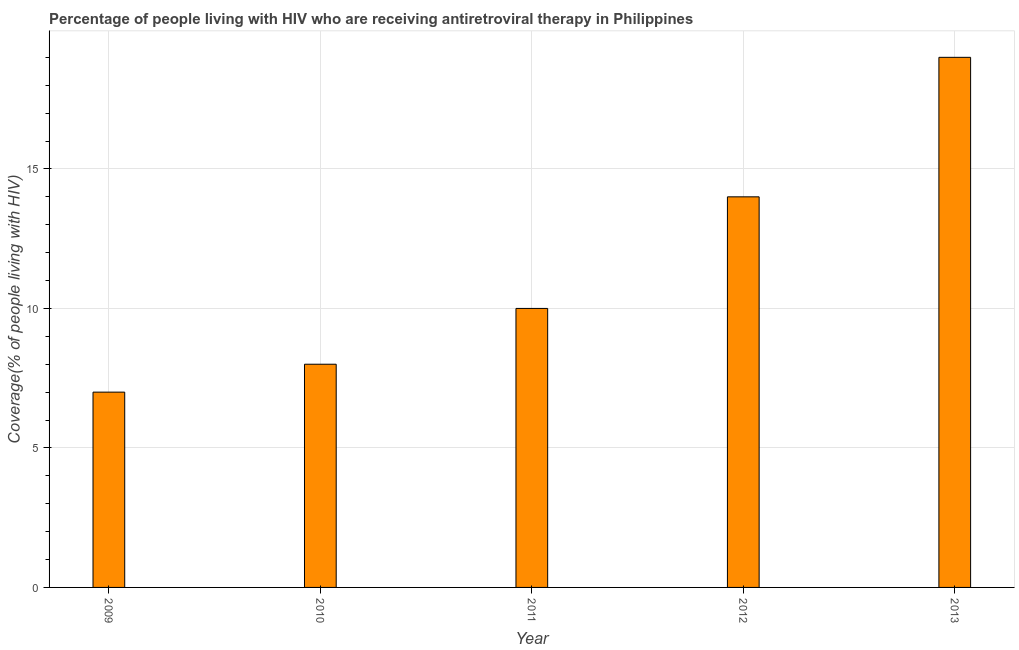What is the title of the graph?
Offer a very short reply. Percentage of people living with HIV who are receiving antiretroviral therapy in Philippines. What is the label or title of the Y-axis?
Give a very brief answer. Coverage(% of people living with HIV). What is the antiretroviral therapy coverage in 2011?
Make the answer very short. 10. Across all years, what is the minimum antiretroviral therapy coverage?
Give a very brief answer. 7. What is the sum of the antiretroviral therapy coverage?
Make the answer very short. 58. What is the difference between the antiretroviral therapy coverage in 2010 and 2011?
Provide a short and direct response. -2. What is the average antiretroviral therapy coverage per year?
Your answer should be very brief. 11. What is the median antiretroviral therapy coverage?
Offer a very short reply. 10. Do a majority of the years between 2009 and 2010 (inclusive) have antiretroviral therapy coverage greater than 7 %?
Give a very brief answer. No. Is the antiretroviral therapy coverage in 2010 less than that in 2013?
Keep it short and to the point. Yes. How many bars are there?
Provide a short and direct response. 5. Are all the bars in the graph horizontal?
Ensure brevity in your answer.  No. How many years are there in the graph?
Your answer should be compact. 5. Are the values on the major ticks of Y-axis written in scientific E-notation?
Ensure brevity in your answer.  No. What is the Coverage(% of people living with HIV) of 2009?
Your answer should be very brief. 7. What is the Coverage(% of people living with HIV) of 2012?
Offer a very short reply. 14. What is the Coverage(% of people living with HIV) of 2013?
Provide a succinct answer. 19. What is the difference between the Coverage(% of people living with HIV) in 2009 and 2011?
Give a very brief answer. -3. What is the difference between the Coverage(% of people living with HIV) in 2009 and 2012?
Make the answer very short. -7. What is the difference between the Coverage(% of people living with HIV) in 2009 and 2013?
Give a very brief answer. -12. What is the difference between the Coverage(% of people living with HIV) in 2010 and 2012?
Offer a very short reply. -6. What is the difference between the Coverage(% of people living with HIV) in 2011 and 2012?
Ensure brevity in your answer.  -4. What is the difference between the Coverage(% of people living with HIV) in 2012 and 2013?
Your answer should be compact. -5. What is the ratio of the Coverage(% of people living with HIV) in 2009 to that in 2013?
Offer a very short reply. 0.37. What is the ratio of the Coverage(% of people living with HIV) in 2010 to that in 2011?
Provide a succinct answer. 0.8. What is the ratio of the Coverage(% of people living with HIV) in 2010 to that in 2012?
Your answer should be very brief. 0.57. What is the ratio of the Coverage(% of people living with HIV) in 2010 to that in 2013?
Give a very brief answer. 0.42. What is the ratio of the Coverage(% of people living with HIV) in 2011 to that in 2012?
Ensure brevity in your answer.  0.71. What is the ratio of the Coverage(% of people living with HIV) in 2011 to that in 2013?
Ensure brevity in your answer.  0.53. What is the ratio of the Coverage(% of people living with HIV) in 2012 to that in 2013?
Give a very brief answer. 0.74. 